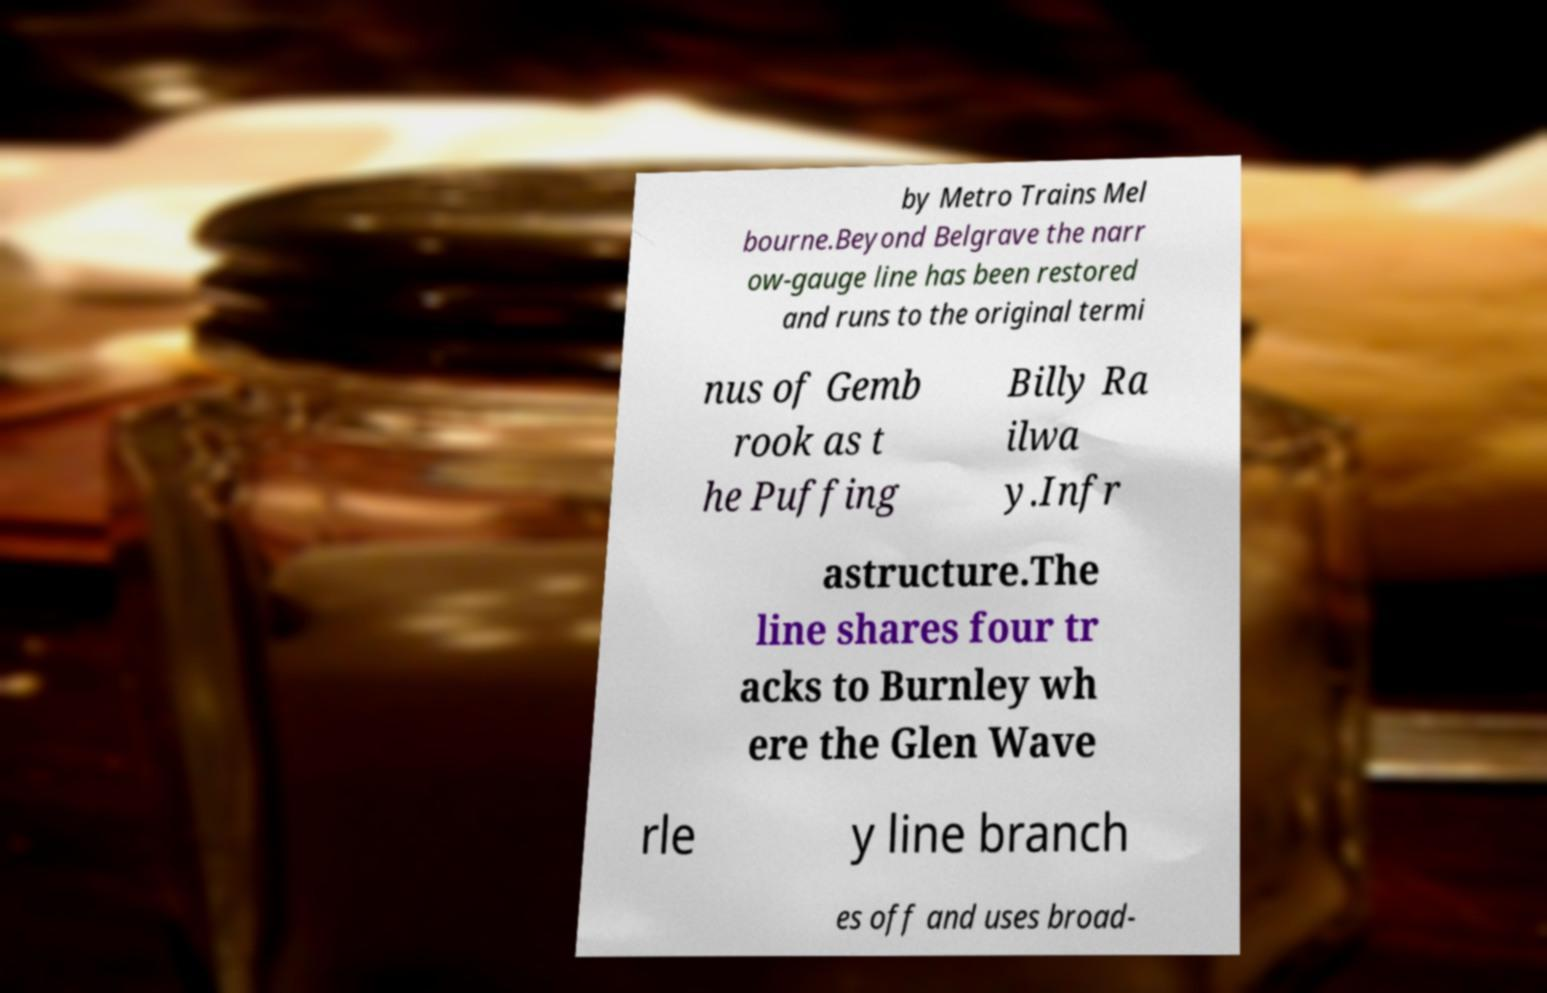Could you assist in decoding the text presented in this image and type it out clearly? by Metro Trains Mel bourne.Beyond Belgrave the narr ow-gauge line has been restored and runs to the original termi nus of Gemb rook as t he Puffing Billy Ra ilwa y.Infr astructure.The line shares four tr acks to Burnley wh ere the Glen Wave rle y line branch es off and uses broad- 